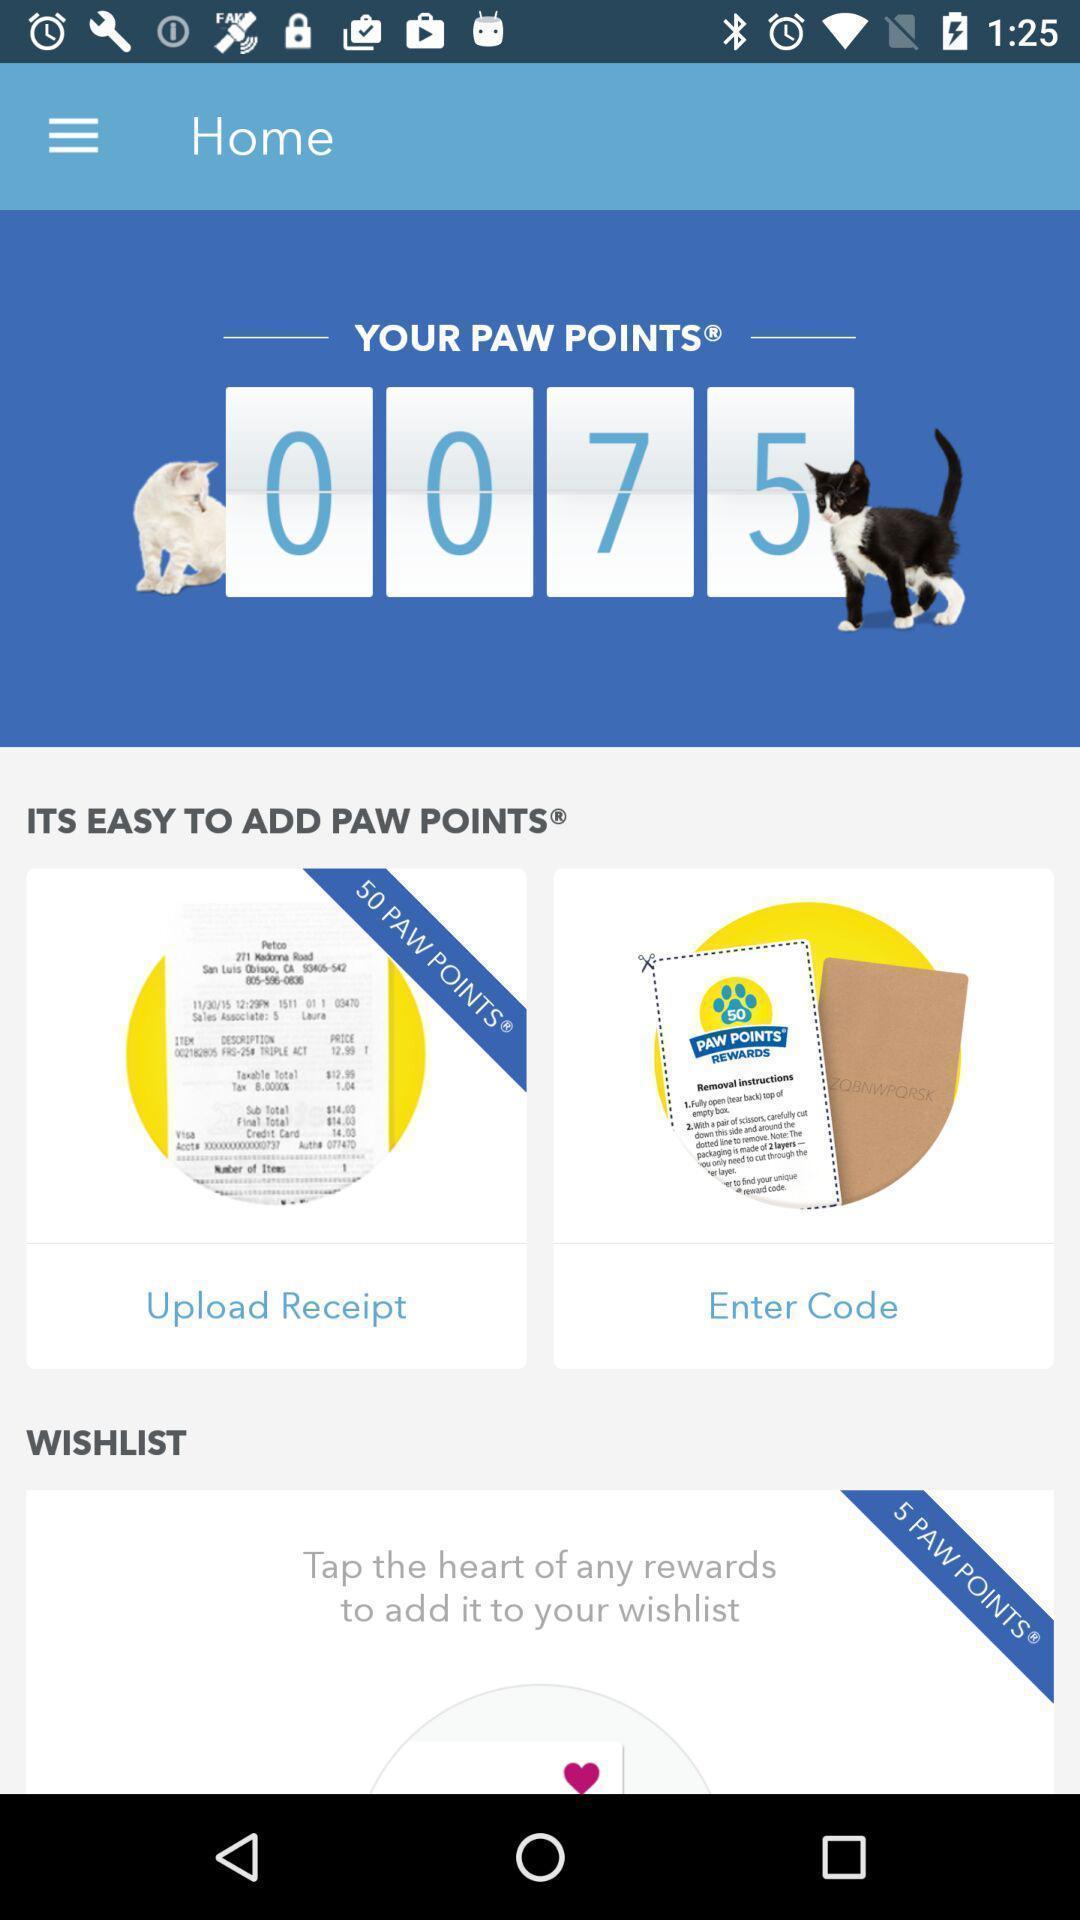Tell me what you see in this picture. Screen shows home page. 